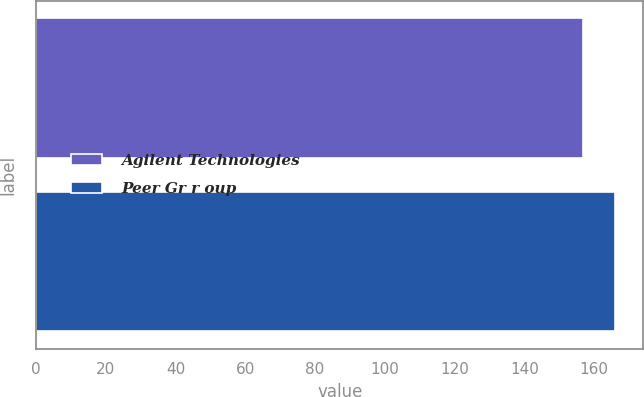Convert chart. <chart><loc_0><loc_0><loc_500><loc_500><bar_chart><fcel>Agilent Technologies<fcel>Peer Gr r oup<nl><fcel>156.67<fcel>165.85<nl></chart> 